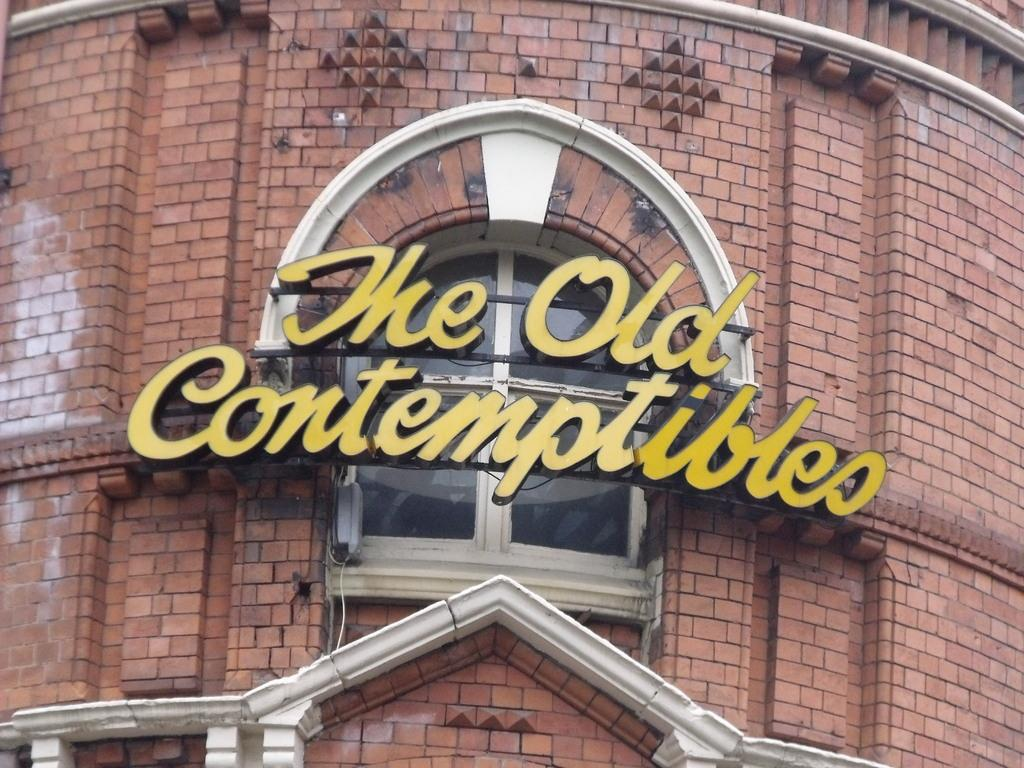What type of structure is visible in the image? There is a building in the image. What material is used for the wall of the building? There is a brick wall in the image. What is placed on the brick wall? There is a name board in the image. What is behind the name board? There is a glass window behind the name board. Is there a stranger in the image who feels shame for being caught by the prison guards? There is no stranger or prison in the image, and therefore no such situation can be observed. 